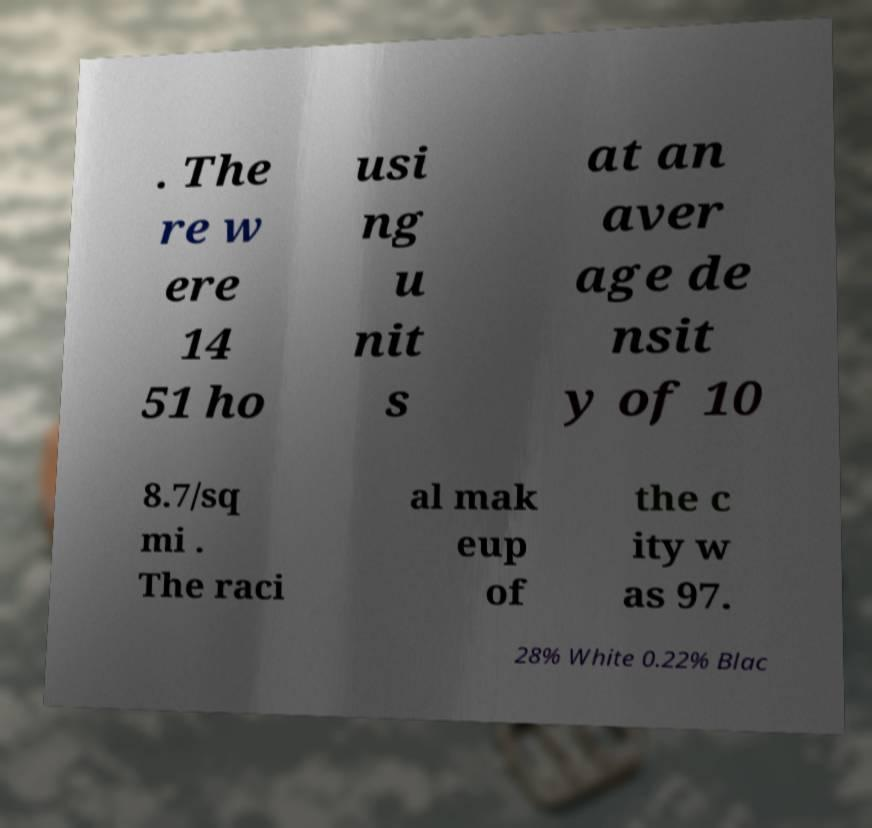Please identify and transcribe the text found in this image. . The re w ere 14 51 ho usi ng u nit s at an aver age de nsit y of 10 8.7/sq mi . The raci al mak eup of the c ity w as 97. 28% White 0.22% Blac 